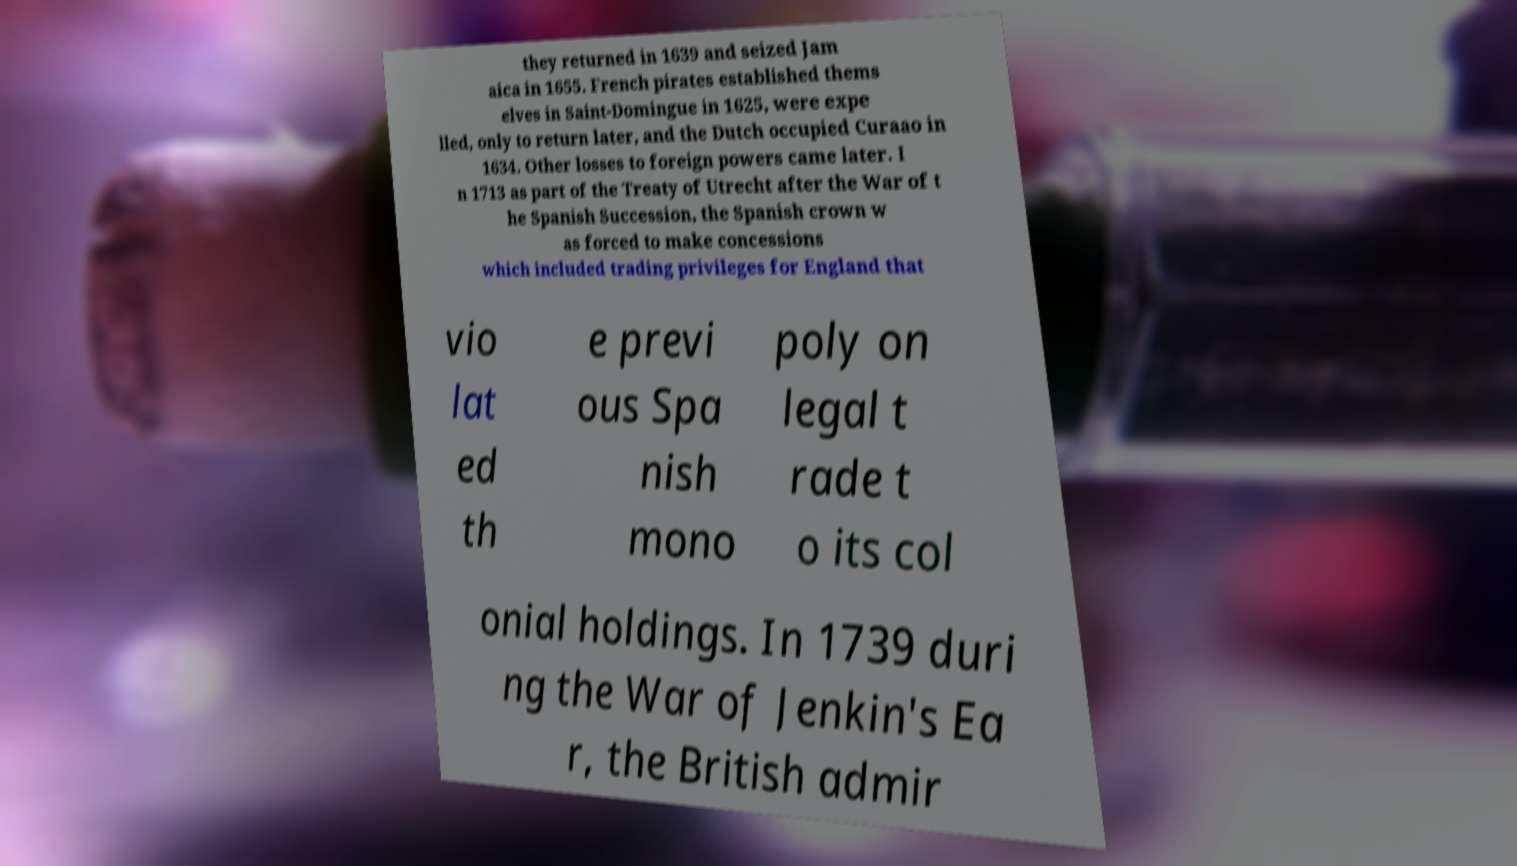Can you read and provide the text displayed in the image?This photo seems to have some interesting text. Can you extract and type it out for me? they returned in 1639 and seized Jam aica in 1655. French pirates established thems elves in Saint-Domingue in 1625, were expe lled, only to return later, and the Dutch occupied Curaao in 1634. Other losses to foreign powers came later. I n 1713 as part of the Treaty of Utrecht after the War of t he Spanish Succession, the Spanish crown w as forced to make concessions which included trading privileges for England that vio lat ed th e previ ous Spa nish mono poly on legal t rade t o its col onial holdings. In 1739 duri ng the War of Jenkin's Ea r, the British admir 